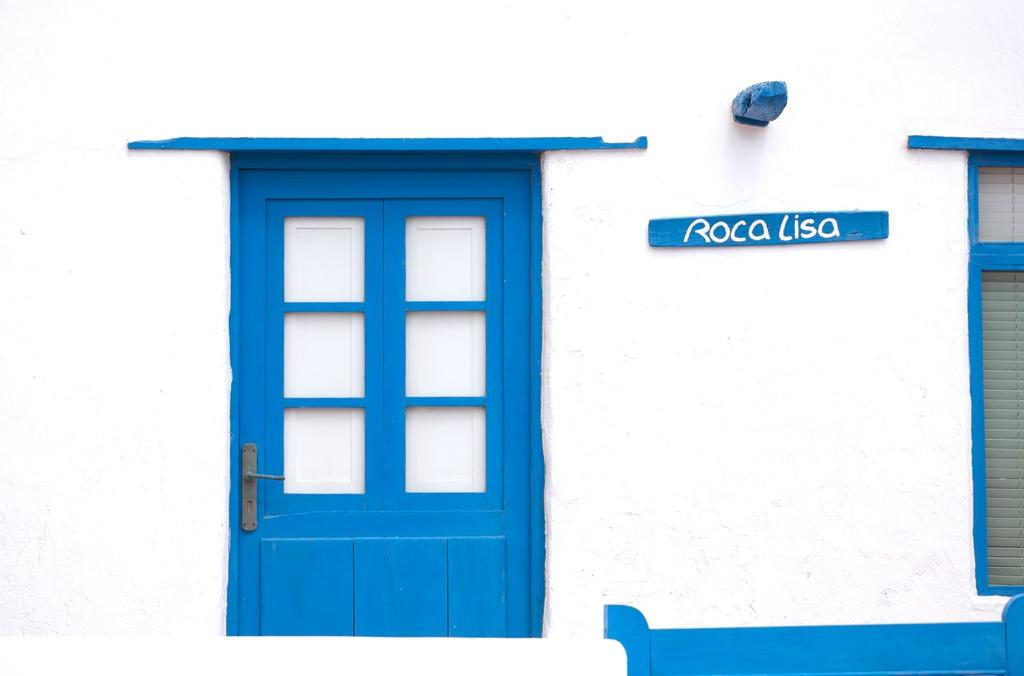What type of opening can be seen in the image? There is a door in the image. What other object is present in the image? There is a board in the image. What allows natural light to enter the space in the image? There is a window in the image. What type of bean is visible in the image? There is no bean present in the image. How does the mouth in the image contribute to the overall scene? There is no mouth present in the image. 